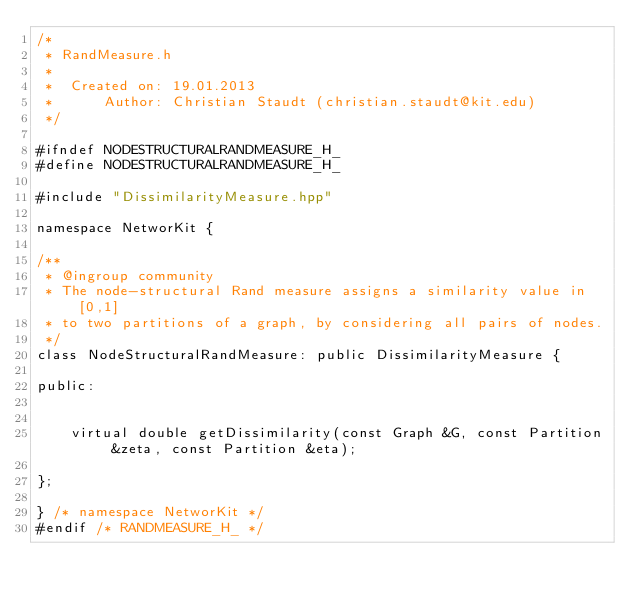Convert code to text. <code><loc_0><loc_0><loc_500><loc_500><_C++_>/*
 * RandMeasure.h
 *
 *  Created on: 19.01.2013
 *      Author: Christian Staudt (christian.staudt@kit.edu)
 */

#ifndef NODESTRUCTURALRANDMEASURE_H_
#define NODESTRUCTURALRANDMEASURE_H_

#include "DissimilarityMeasure.hpp"

namespace NetworKit {

/**
 * @ingroup community
 * The node-structural Rand measure assigns a similarity value in [0,1]
 * to two partitions of a graph, by considering all pairs of nodes.
 */
class NodeStructuralRandMeasure: public DissimilarityMeasure {

public:


	virtual double getDissimilarity(const Graph &G, const Partition &zeta, const Partition &eta);

};

} /* namespace NetworKit */
#endif /* RANDMEASURE_H_ */
</code> 